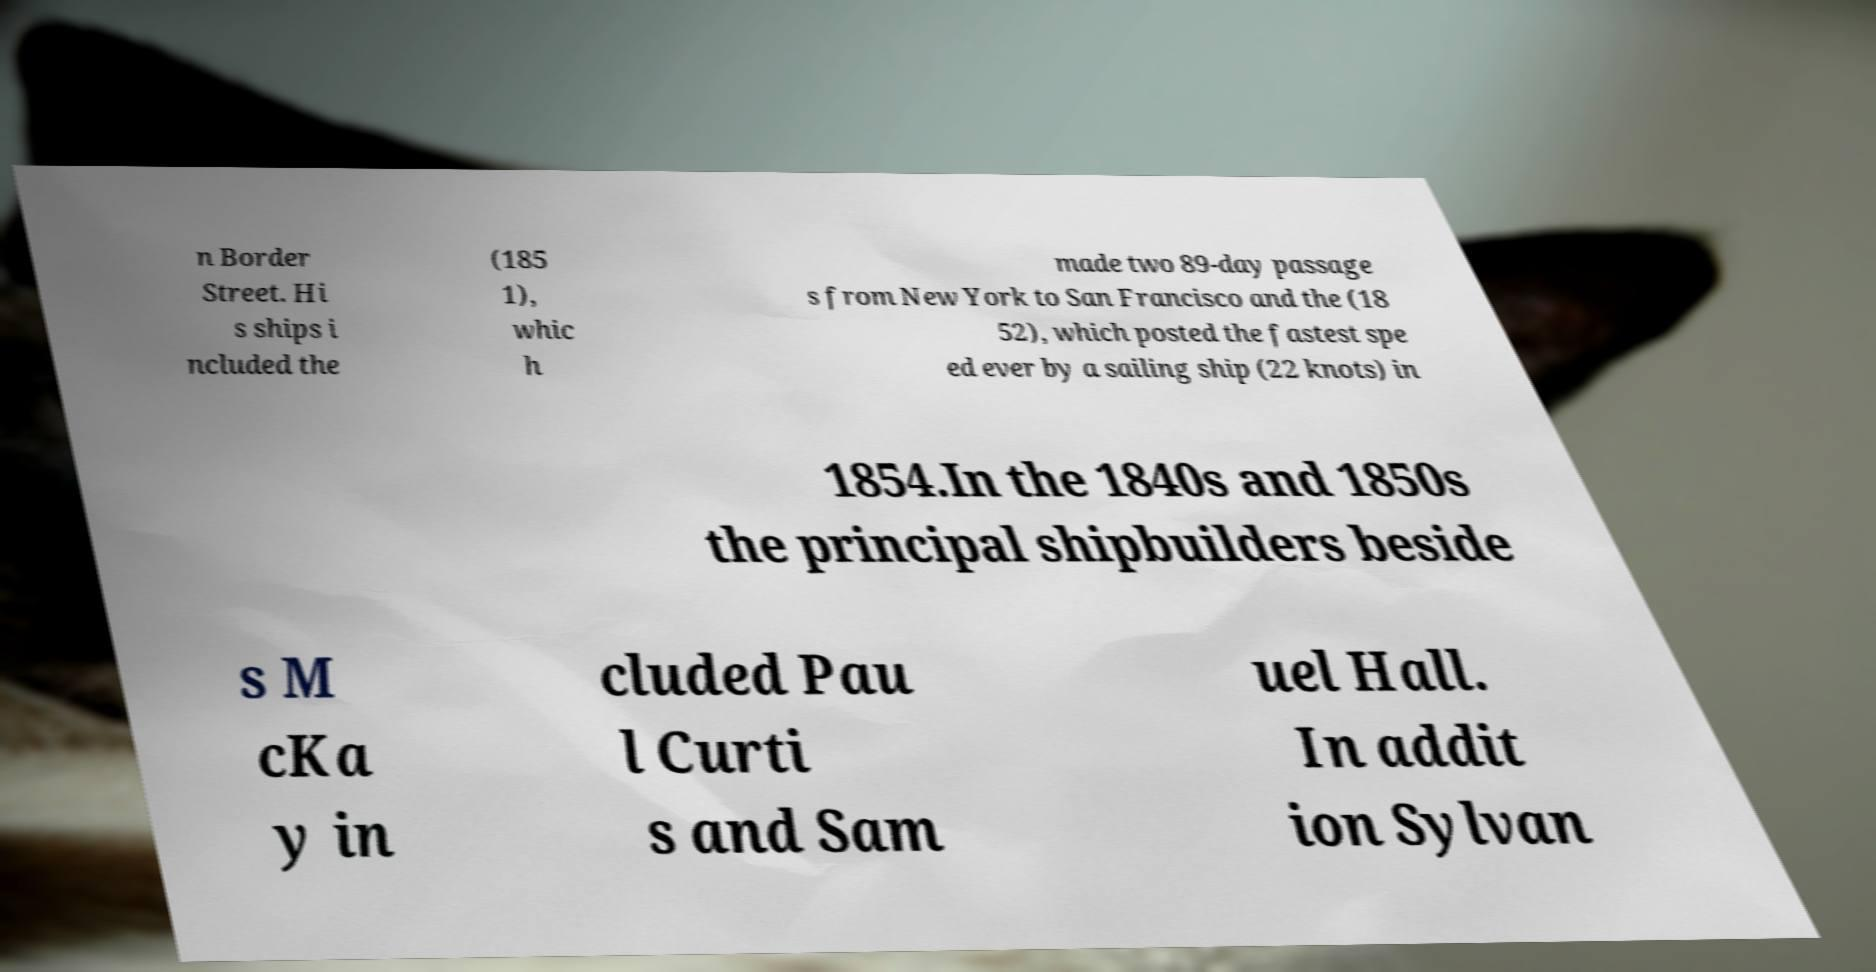Can you accurately transcribe the text from the provided image for me? n Border Street. Hi s ships i ncluded the (185 1), whic h made two 89-day passage s from New York to San Francisco and the (18 52), which posted the fastest spe ed ever by a sailing ship (22 knots) in 1854.In the 1840s and 1850s the principal shipbuilders beside s M cKa y in cluded Pau l Curti s and Sam uel Hall. In addit ion Sylvan 